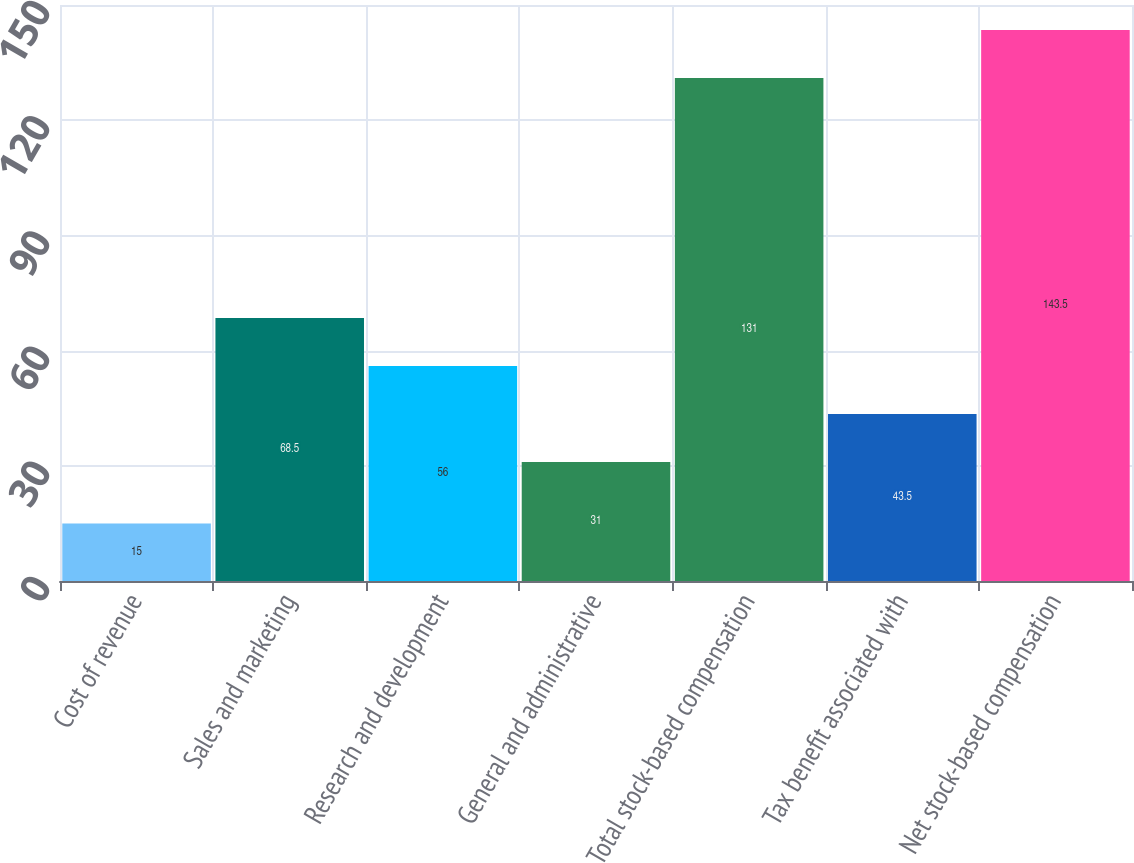Convert chart. <chart><loc_0><loc_0><loc_500><loc_500><bar_chart><fcel>Cost of revenue<fcel>Sales and marketing<fcel>Research and development<fcel>General and administrative<fcel>Total stock-based compensation<fcel>Tax benefit associated with<fcel>Net stock-based compensation<nl><fcel>15<fcel>68.5<fcel>56<fcel>31<fcel>131<fcel>43.5<fcel>143.5<nl></chart> 